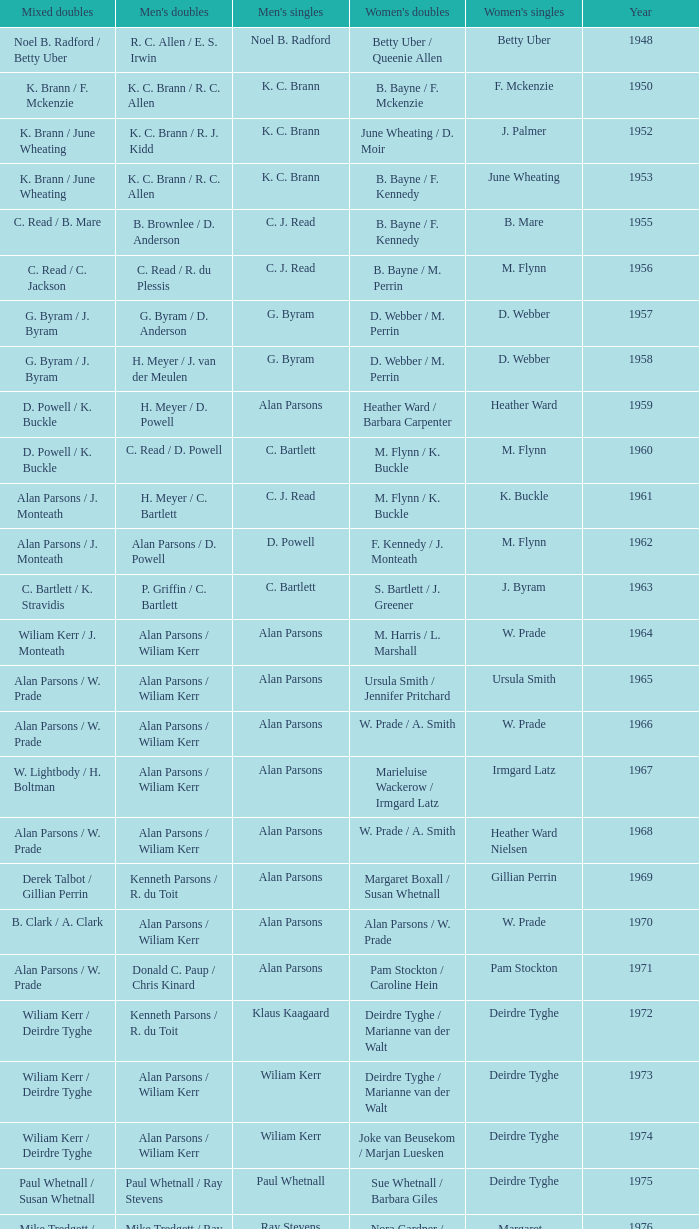Which Men's doubles have a Year smaller than 1960, and Men's singles of noel b. radford? R. C. Allen / E. S. Irwin. 